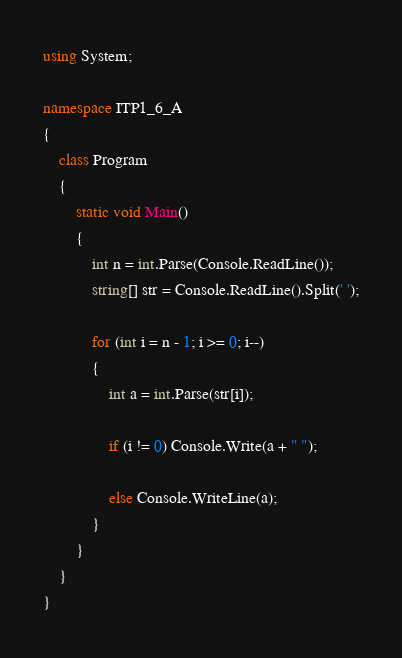<code> <loc_0><loc_0><loc_500><loc_500><_C#_>using System;

namespace ITP1_6_A
{
    class Program
    {
        static void Main()
        {
            int n = int.Parse(Console.ReadLine());
            string[] str = Console.ReadLine().Split(' ');

            for (int i = n - 1; i >= 0; i--)
            {
                int a = int.Parse(str[i]);

                if (i != 0) Console.Write(a + " ");

                else Console.WriteLine(a);
            }
        }
    }
}</code> 